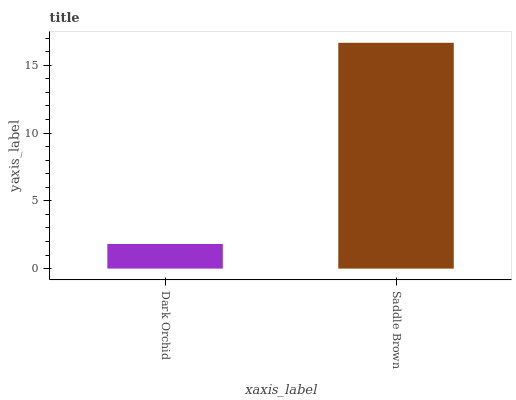Is Saddle Brown the minimum?
Answer yes or no. No. Is Saddle Brown greater than Dark Orchid?
Answer yes or no. Yes. Is Dark Orchid less than Saddle Brown?
Answer yes or no. Yes. Is Dark Orchid greater than Saddle Brown?
Answer yes or no. No. Is Saddle Brown less than Dark Orchid?
Answer yes or no. No. Is Saddle Brown the high median?
Answer yes or no. Yes. Is Dark Orchid the low median?
Answer yes or no. Yes. Is Dark Orchid the high median?
Answer yes or no. No. Is Saddle Brown the low median?
Answer yes or no. No. 